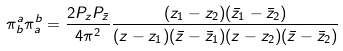<formula> <loc_0><loc_0><loc_500><loc_500>\pi ^ { a } _ { b } \pi ^ { b } _ { a } = \frac { 2 P _ { z } P _ { \bar { z } } } { 4 \pi ^ { 2 } } \frac { ( z _ { 1 } - z _ { 2 } ) ( \bar { z } _ { 1 } - \bar { z } _ { 2 } ) } { ( z - z _ { 1 } ) ( \bar { z } - \bar { z } _ { 1 } ) ( z - z _ { 2 } ) ( \bar { z } - \bar { z } _ { 2 } ) }</formula> 